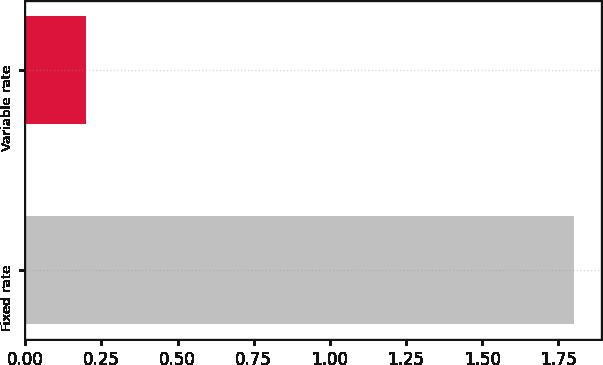Convert chart to OTSL. <chart><loc_0><loc_0><loc_500><loc_500><bar_chart><fcel>Fixed rate<fcel>Variable rate<nl><fcel>1.8<fcel>0.2<nl></chart> 